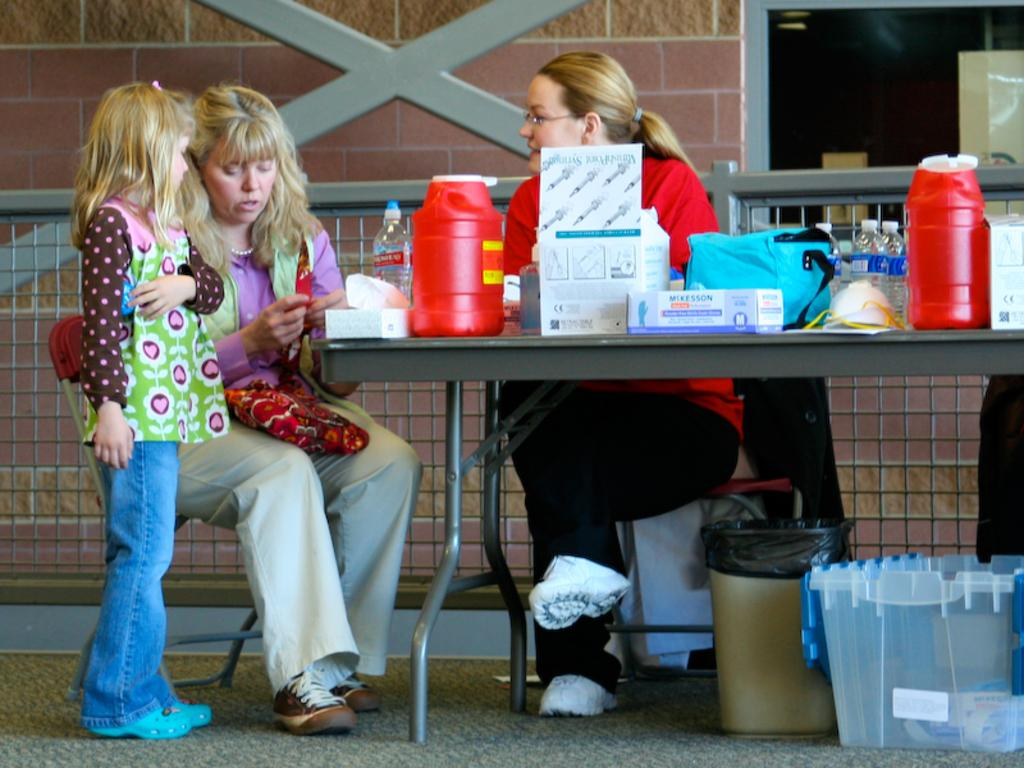What is the woman in the image doing? The woman is sitting at a table. What can be seen on the table in front of the sitting woman? The woman has medicines and other articles on the table. Who is coming towards the sitting woman? Another woman is approaching the sitting woman. Who is accompanying the approaching woman? There is a girl with the approaching woman. What type of truck can be seen in the background of the image? There is no truck visible in the image. How many beds are present in the image? There are no beds present in the image. 